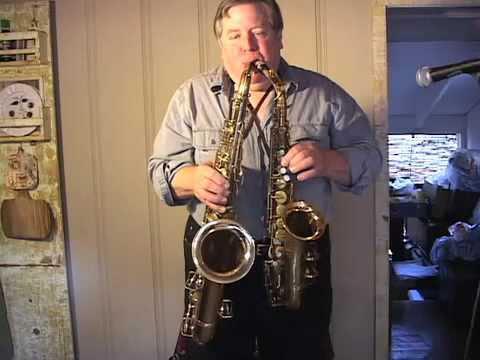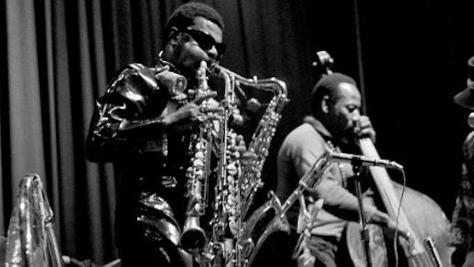The first image is the image on the left, the second image is the image on the right. Evaluate the accuracy of this statement regarding the images: "There are three or more people clearly visible.". Is it true? Answer yes or no. Yes. The first image is the image on the left, the second image is the image on the right. Considering the images on both sides, is "An image shows a sax player wearing a tall black hat and glasses." valid? Answer yes or no. No. 